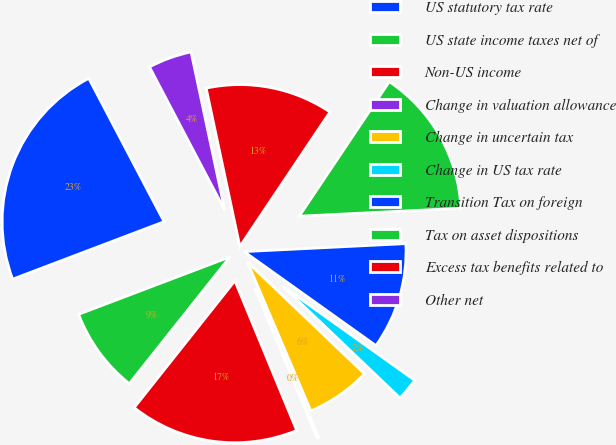Convert chart to OTSL. <chart><loc_0><loc_0><loc_500><loc_500><pie_chart><fcel>US statutory tax rate<fcel>US state income taxes net of<fcel>Non-US income<fcel>Change in valuation allowance<fcel>Change in uncertain tax<fcel>Change in US tax rate<fcel>Transition Tax on foreign<fcel>Tax on asset dispositions<fcel>Excess tax benefits related to<fcel>Other net<nl><fcel>23.07%<fcel>8.55%<fcel>16.91%<fcel>0.18%<fcel>6.46%<fcel>2.27%<fcel>10.64%<fcel>14.82%<fcel>12.73%<fcel>4.36%<nl></chart> 